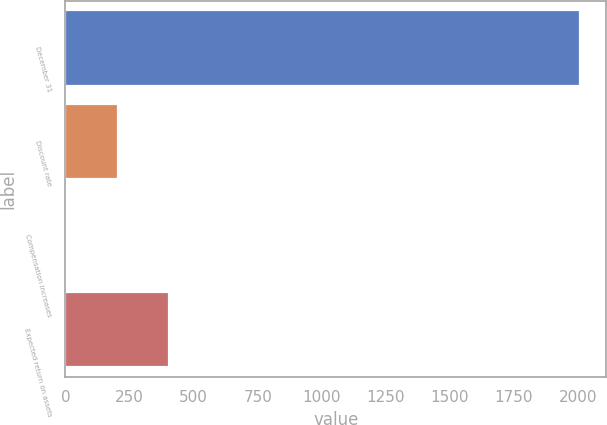Convert chart. <chart><loc_0><loc_0><loc_500><loc_500><bar_chart><fcel>December 31<fcel>Discount rate<fcel>Compensation increases<fcel>Expected return on assets<nl><fcel>2009<fcel>205<fcel>4.56<fcel>405.44<nl></chart> 